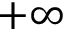Convert formula to latex. <formula><loc_0><loc_0><loc_500><loc_500>+ \infty</formula> 